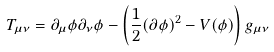<formula> <loc_0><loc_0><loc_500><loc_500>T _ { \mu \nu } = \partial _ { \mu } \phi \partial _ { \nu } \phi - \left ( \frac { 1 } { 2 } ( \partial \phi ) ^ { 2 } - V ( \phi ) \right ) g _ { \mu \nu }</formula> 